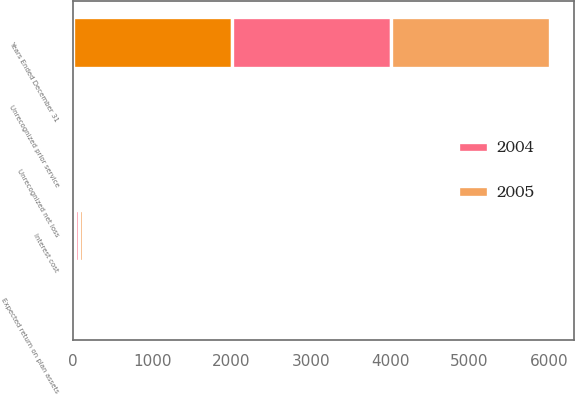Convert chart. <chart><loc_0><loc_0><loc_500><loc_500><stacked_bar_chart><ecel><fcel>Years Ended December 31<fcel>Interest cost<fcel>Expected return on plan assets<fcel>Unrecognized net loss<fcel>Unrecognized prior service<nl><fcel>nan<fcel>2005<fcel>30<fcel>19<fcel>10<fcel>3<nl><fcel>2004<fcel>2004<fcel>46<fcel>21<fcel>14<fcel>4<nl><fcel>2005<fcel>2003<fcel>48<fcel>25<fcel>11<fcel>3<nl></chart> 